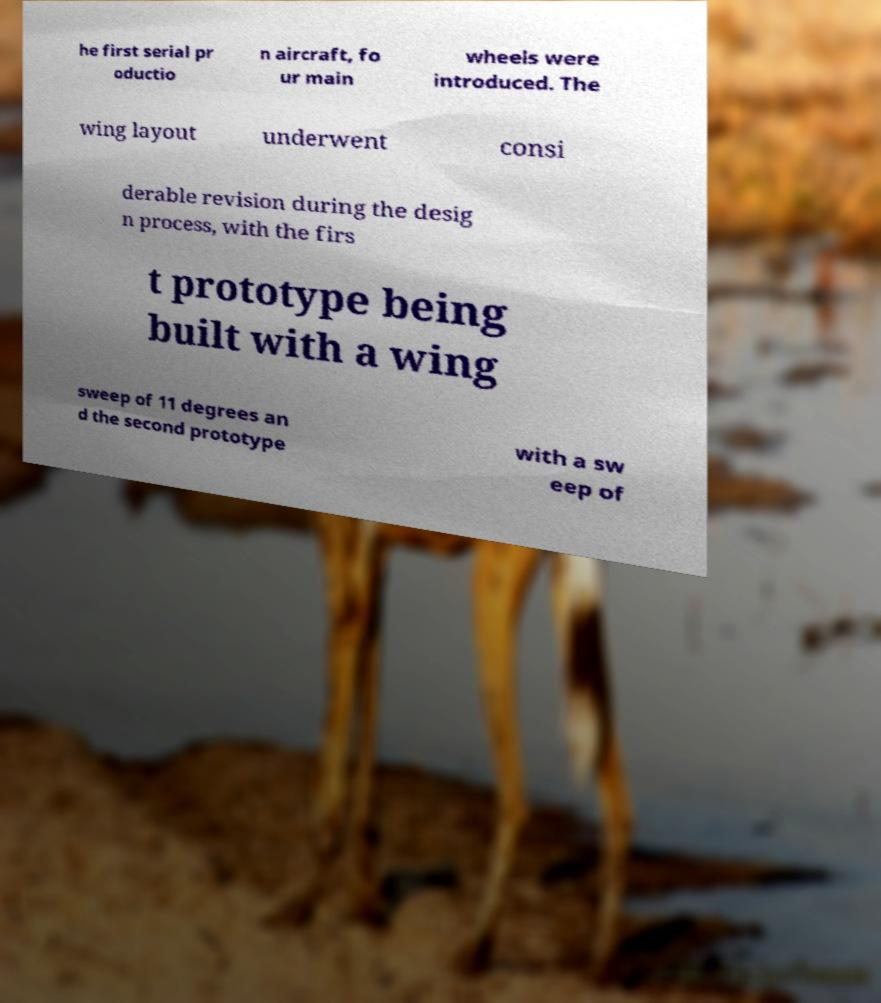Can you accurately transcribe the text from the provided image for me? he first serial pr oductio n aircraft, fo ur main wheels were introduced. The wing layout underwent consi derable revision during the desig n process, with the firs t prototype being built with a wing sweep of 11 degrees an d the second prototype with a sw eep of 